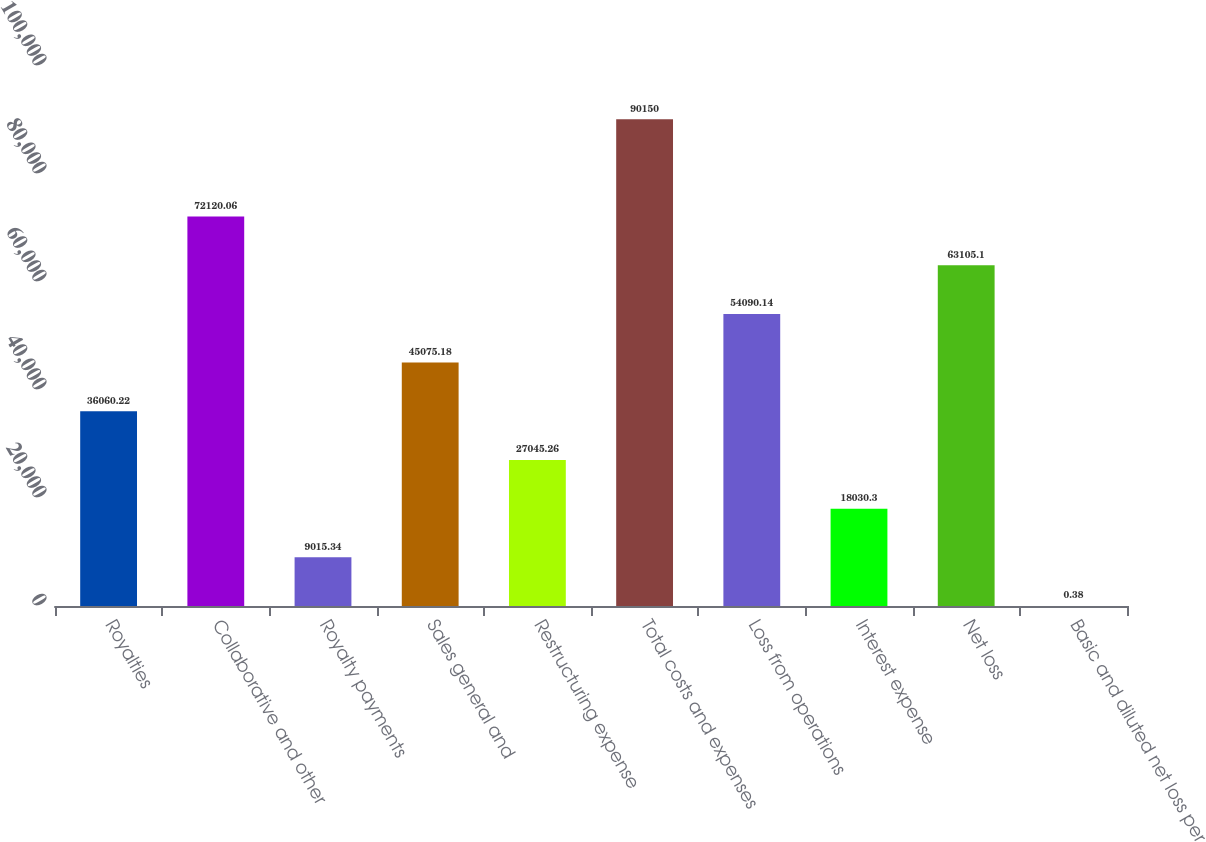<chart> <loc_0><loc_0><loc_500><loc_500><bar_chart><fcel>Royalties<fcel>Collaborative and other<fcel>Royalty payments<fcel>Sales general and<fcel>Restructuring expense<fcel>Total costs and expenses<fcel>Loss from operations<fcel>Interest expense<fcel>Net loss<fcel>Basic and diluted net loss per<nl><fcel>36060.2<fcel>72120.1<fcel>9015.34<fcel>45075.2<fcel>27045.3<fcel>90150<fcel>54090.1<fcel>18030.3<fcel>63105.1<fcel>0.38<nl></chart> 